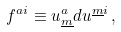<formula> <loc_0><loc_0><loc_500><loc_500>f ^ { a i } \equiv u _ { \underline { m } } ^ { a } d u ^ { \underline { m } i } \, ,</formula> 